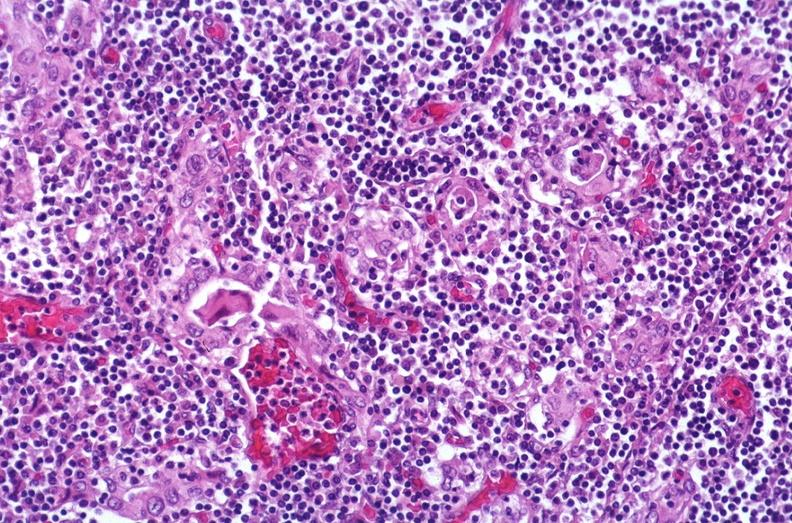s fixed tissue present?
Answer the question using a single word or phrase. No 